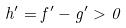Convert formula to latex. <formula><loc_0><loc_0><loc_500><loc_500>h ^ { \prime } = f ^ { \prime } - g ^ { \prime } > 0</formula> 